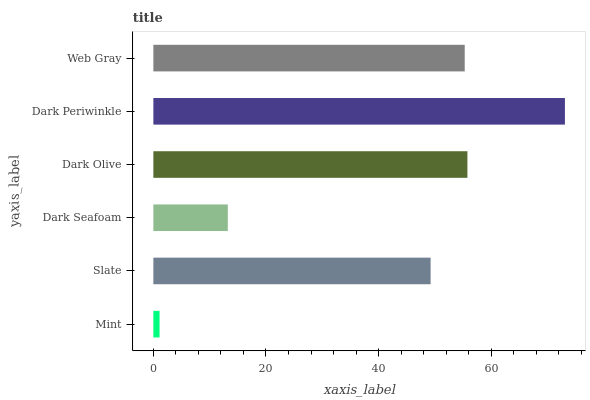Is Mint the minimum?
Answer yes or no. Yes. Is Dark Periwinkle the maximum?
Answer yes or no. Yes. Is Slate the minimum?
Answer yes or no. No. Is Slate the maximum?
Answer yes or no. No. Is Slate greater than Mint?
Answer yes or no. Yes. Is Mint less than Slate?
Answer yes or no. Yes. Is Mint greater than Slate?
Answer yes or no. No. Is Slate less than Mint?
Answer yes or no. No. Is Web Gray the high median?
Answer yes or no. Yes. Is Slate the low median?
Answer yes or no. Yes. Is Dark Seafoam the high median?
Answer yes or no. No. Is Web Gray the low median?
Answer yes or no. No. 